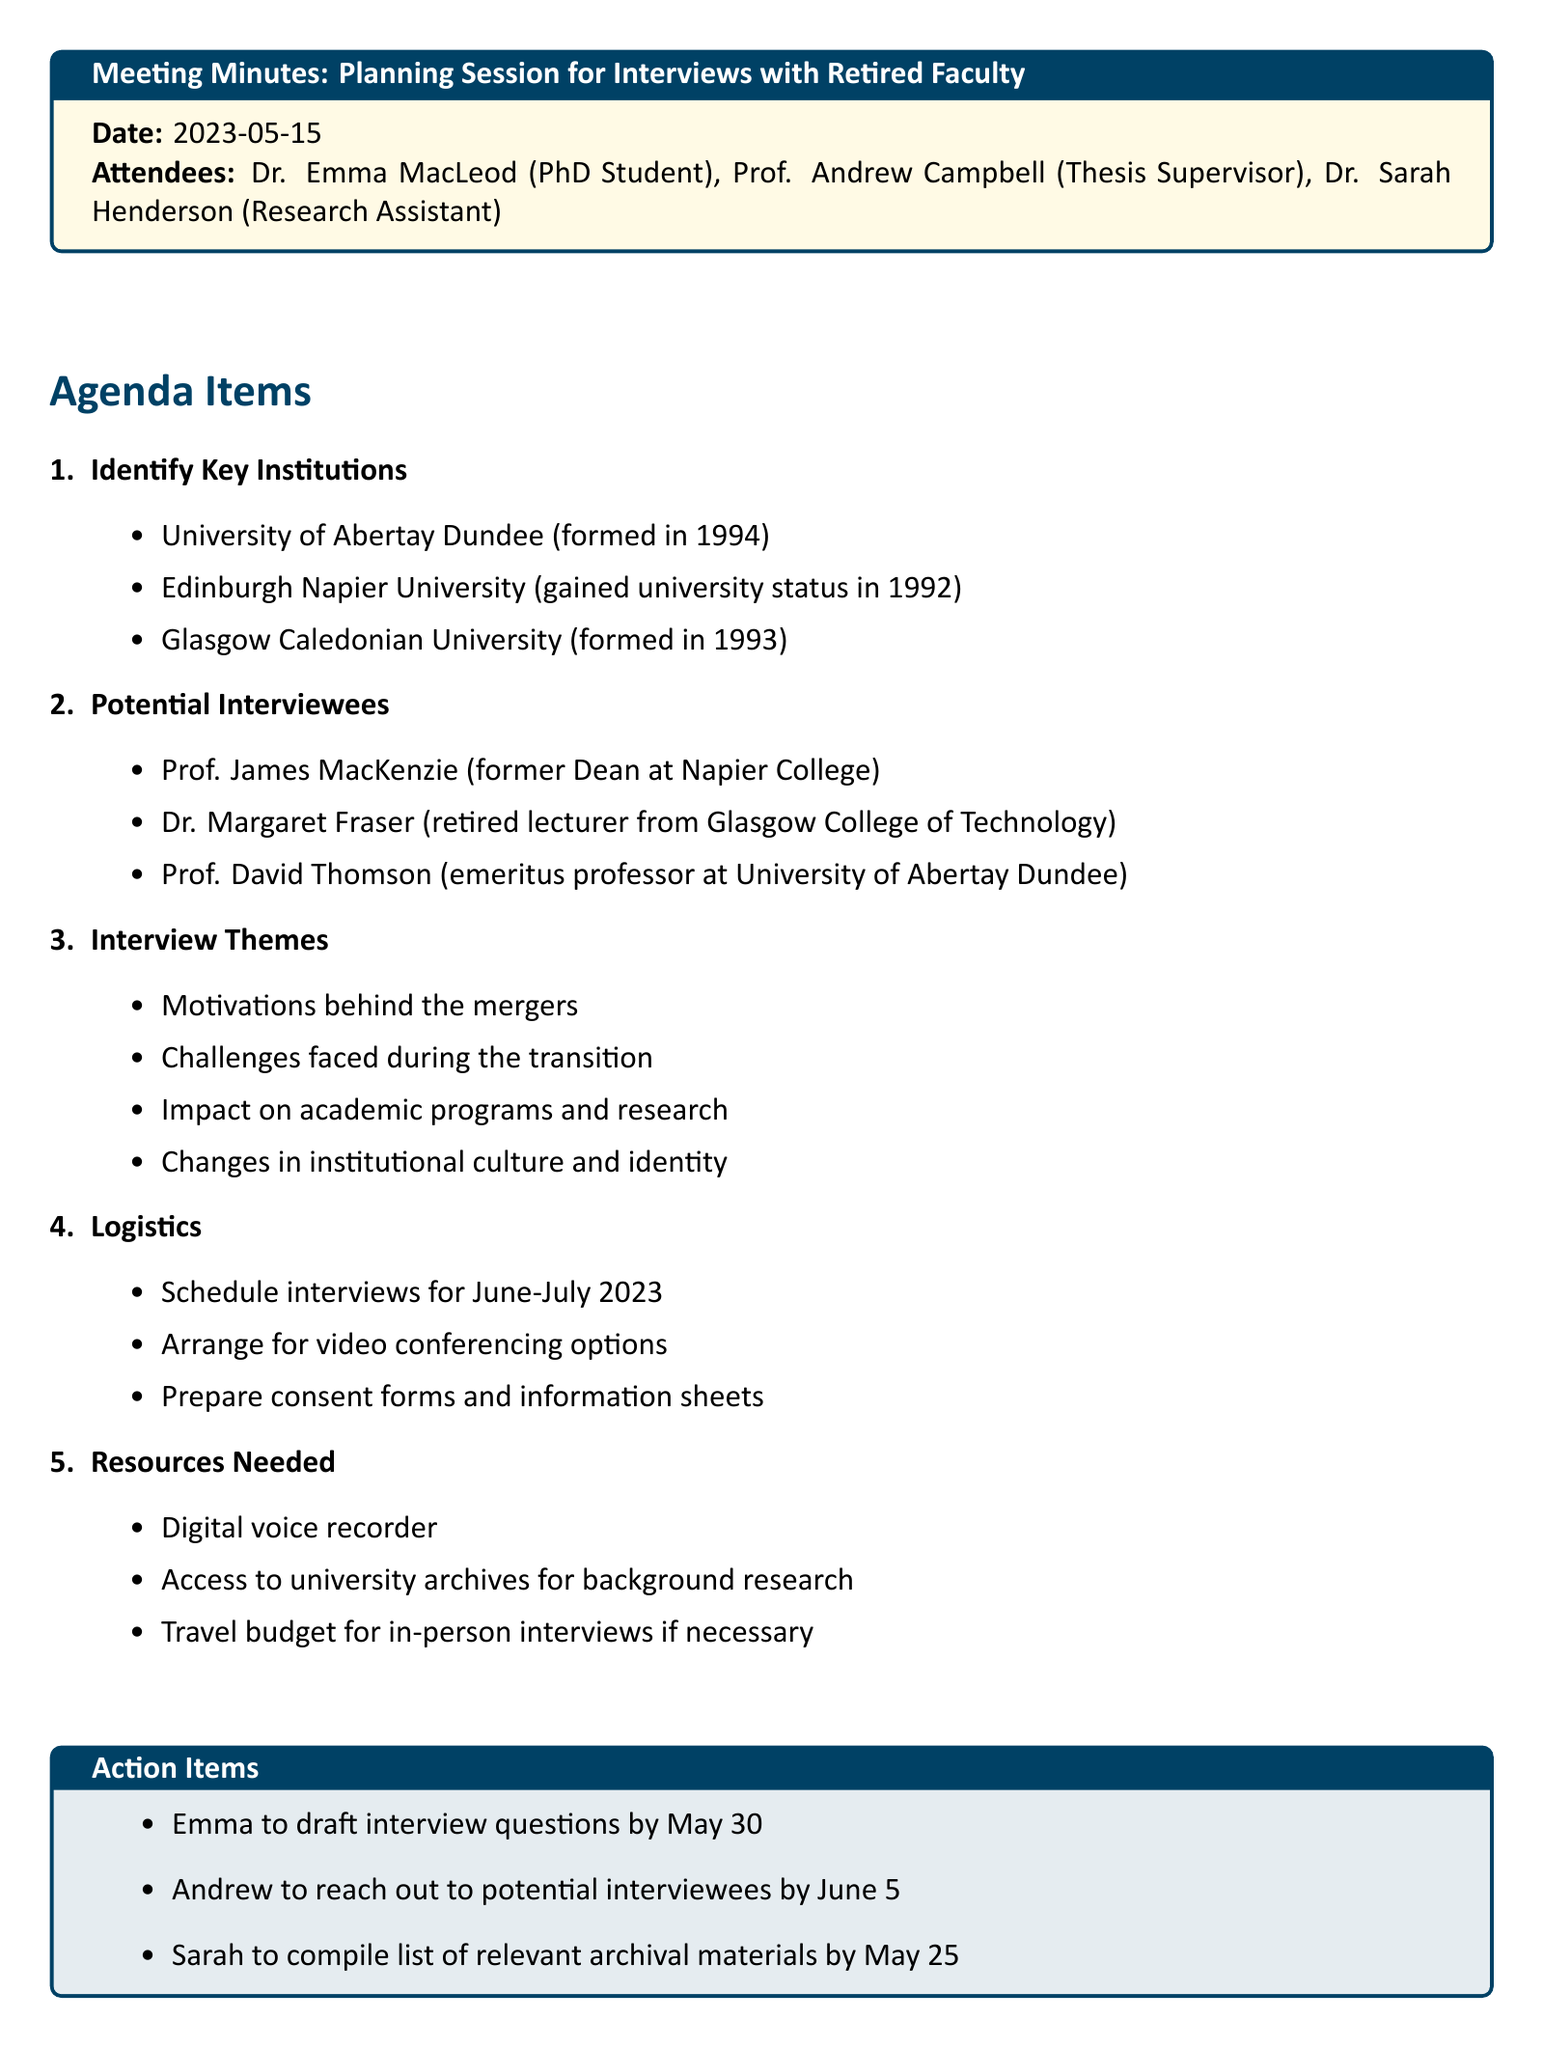what is the date of the meeting? The date of the meeting is specified in the document as the date it took place.
Answer: 2023-05-15 who is a former Dean at Napier College? This information is found under "Potential Interviewees" in the document detailing notable individuals for interviews.
Answer: Prof. James MacKenzie which university gained university status in 1992? The document lists key institutions and their milestones, identifying which university achieved this status.
Answer: Edinburgh Napier University what are the interview themes mentioned in the document? The themes for the interviews are outlined explicitly under "Interview Themes" section, listing the main topics of interest.
Answer: Motivations behind the mergers what is one resource needed for the interviews? The document lists the resources required, which includes items necessary for conducting the interviews effectively.
Answer: Digital voice recorder who is responsible for reaching out to potential interviewees? The action items clarify who will be completing specific tasks, indicating individual responsibilities amongst the attendees.
Answer: Andrew when are the interviews scheduled to be held? The document clearly states the timeframe for when the interviews are planned to take place, which is indicated in the logistics section.
Answer: June-July 2023 what action item is Emma tasked with? The action items list the duties assigned to each attendee, showing specific contributions expected from them.
Answer: to draft interview questions by May 30 